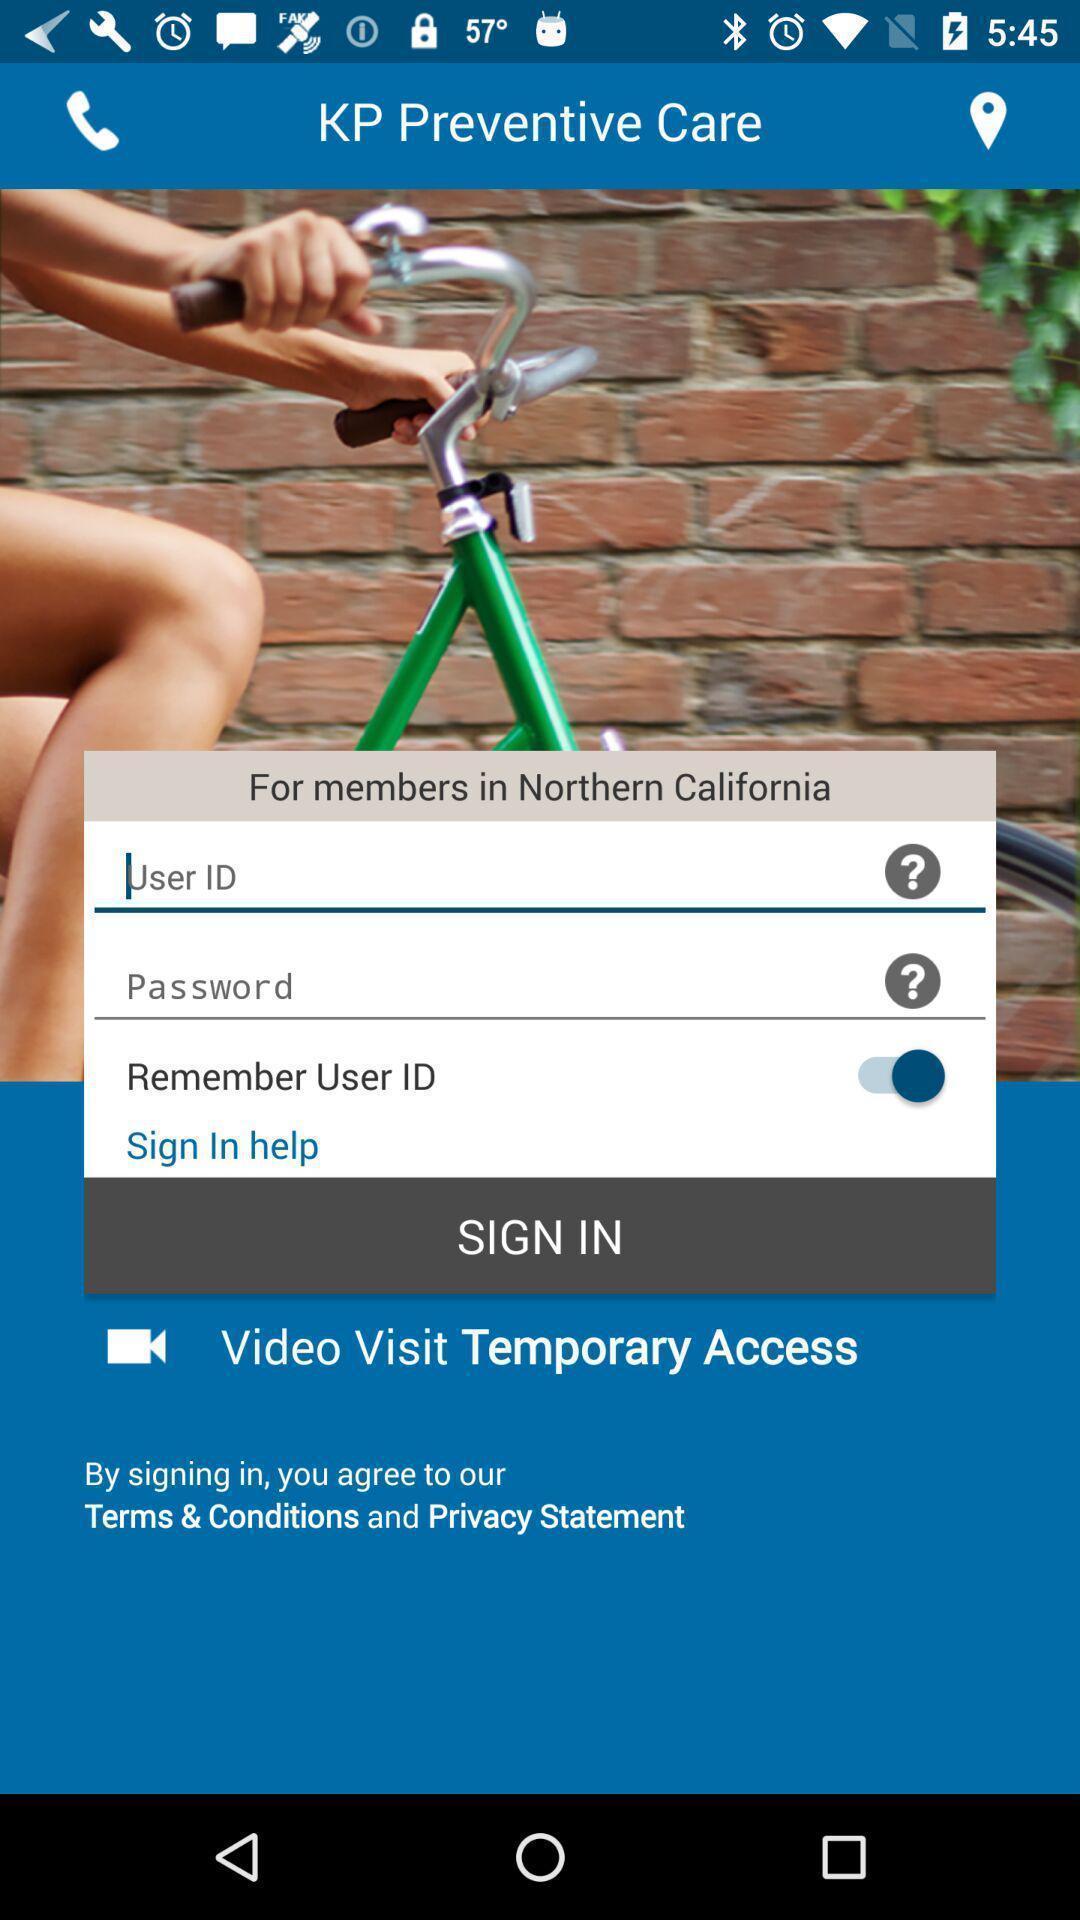Summarize the information in this screenshot. Sign in page for the application with entry details. 